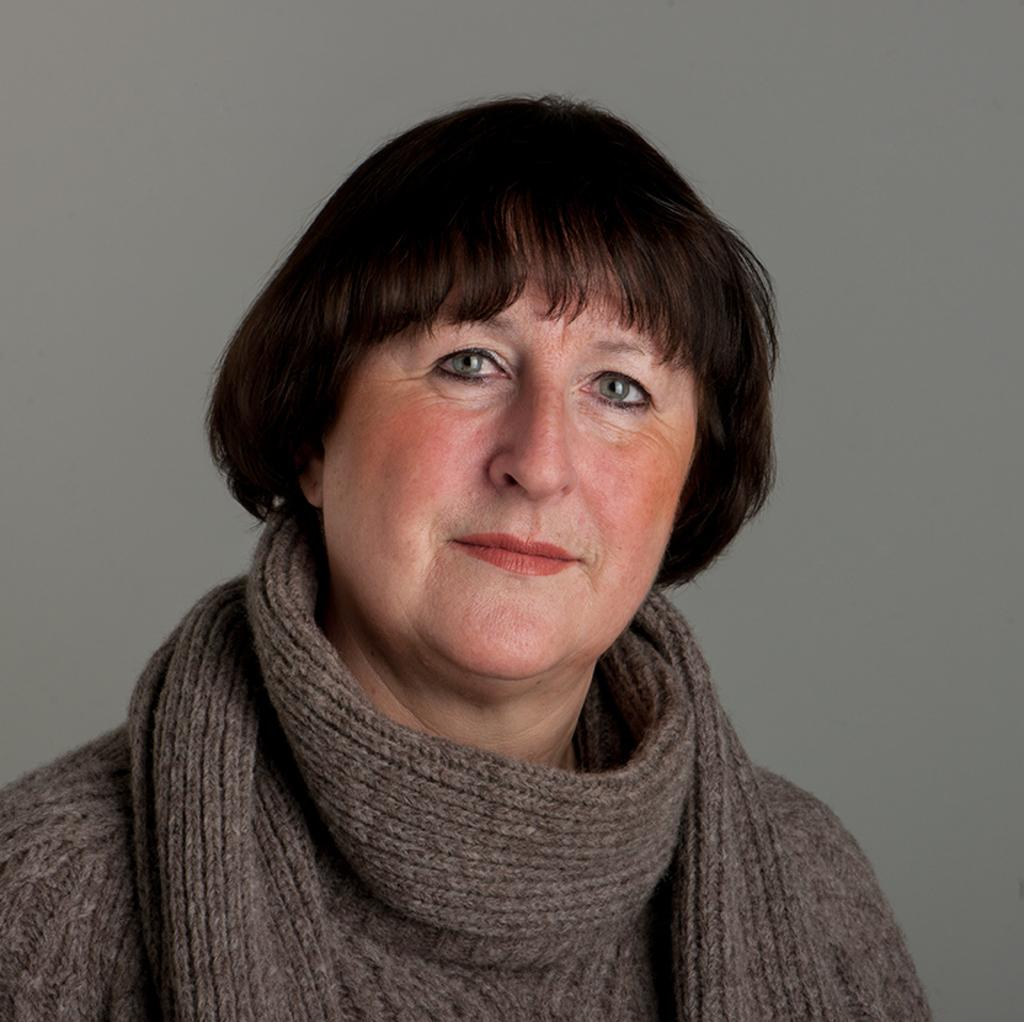Who or what is the main subject in the image? There is a person in the image. What is the person wearing? The person is wearing a brown dress. What color is the background of the image? The background of the image is in ash color. What type of flesh can be seen on the person's face in the image? There is no flesh visible on the person's face in the image, as the person is wearing a brown dress, and the focus is on the clothing and background color. 